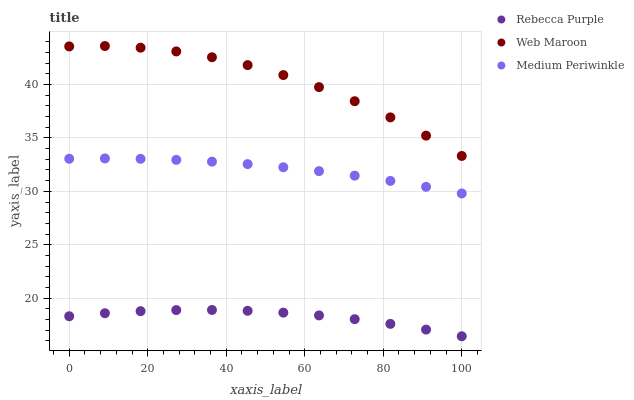Does Rebecca Purple have the minimum area under the curve?
Answer yes or no. Yes. Does Web Maroon have the maximum area under the curve?
Answer yes or no. Yes. Does Web Maroon have the minimum area under the curve?
Answer yes or no. No. Does Rebecca Purple have the maximum area under the curve?
Answer yes or no. No. Is Medium Periwinkle the smoothest?
Answer yes or no. Yes. Is Web Maroon the roughest?
Answer yes or no. Yes. Is Rebecca Purple the smoothest?
Answer yes or no. No. Is Rebecca Purple the roughest?
Answer yes or no. No. Does Rebecca Purple have the lowest value?
Answer yes or no. Yes. Does Web Maroon have the lowest value?
Answer yes or no. No. Does Web Maroon have the highest value?
Answer yes or no. Yes. Does Rebecca Purple have the highest value?
Answer yes or no. No. Is Rebecca Purple less than Web Maroon?
Answer yes or no. Yes. Is Web Maroon greater than Medium Periwinkle?
Answer yes or no. Yes. Does Rebecca Purple intersect Web Maroon?
Answer yes or no. No. 